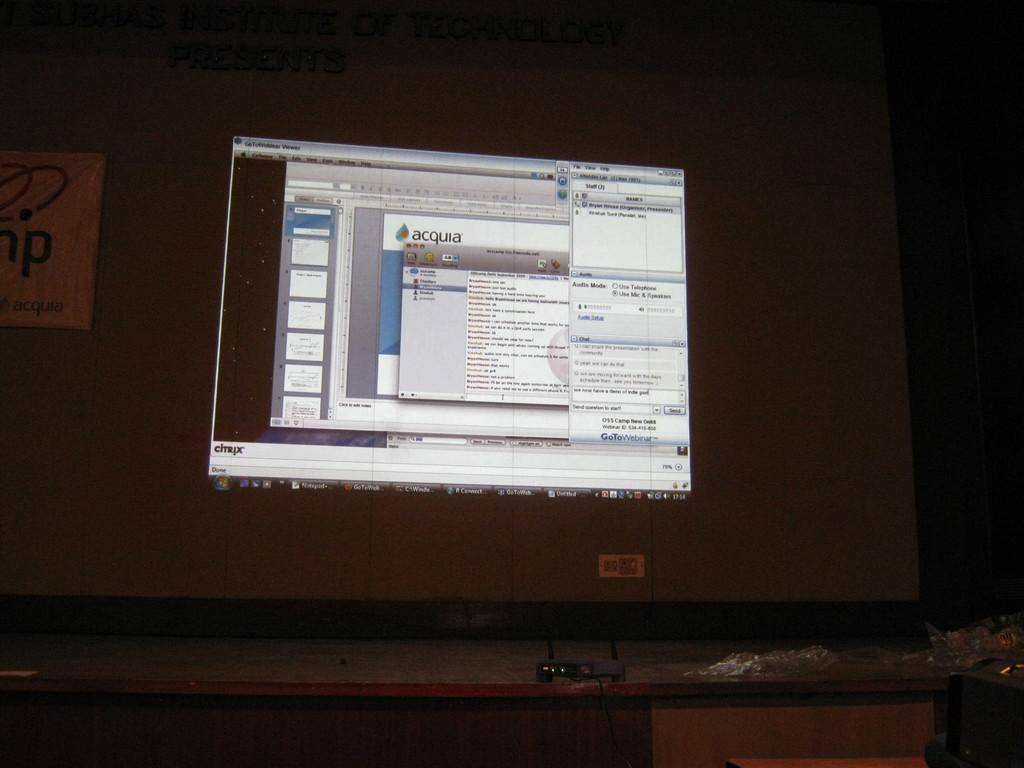<image>
Share a concise interpretation of the image provided. a computer with acquia on the front of it 